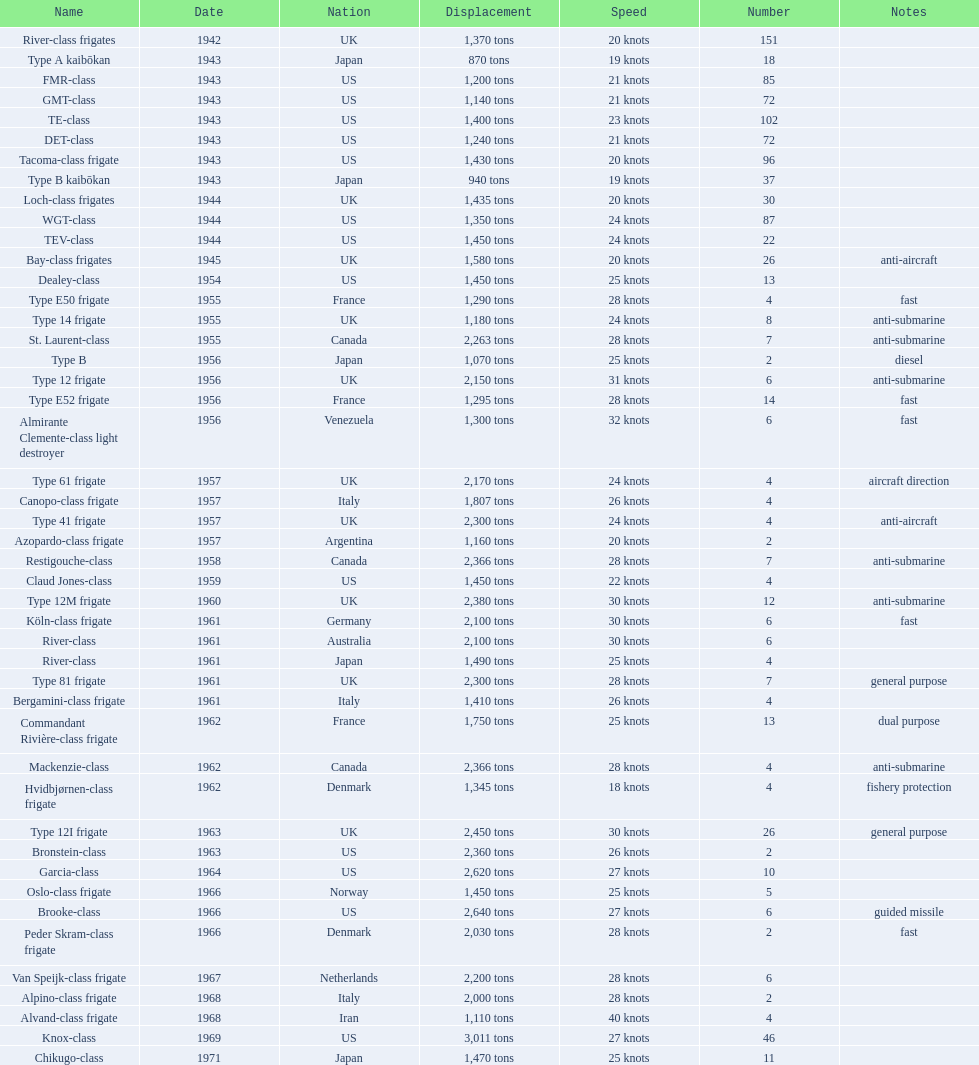Italy employed the alpino-class frigate in 196 28 knots. 